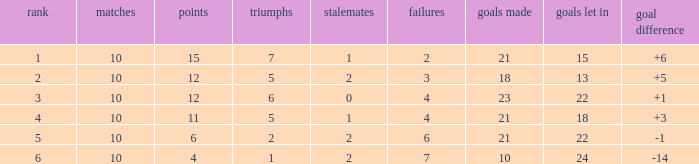Can you tell me the total number of Wins that has the Draws larger than 0, and the Points of 11? 1.0. 